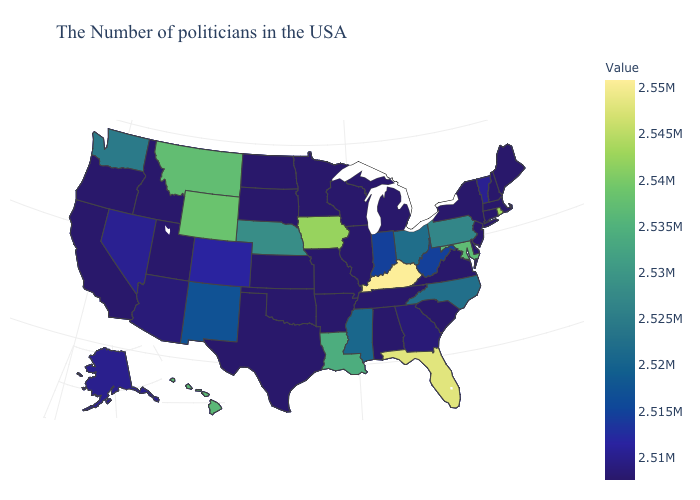Does Michigan have a higher value than West Virginia?
Answer briefly. No. Among the states that border New Mexico , which have the highest value?
Write a very short answer. Colorado. Which states have the lowest value in the USA?
Concise answer only. Maine, Massachusetts, New Hampshire, Connecticut, New York, New Jersey, Delaware, Virginia, South Carolina, Michigan, Alabama, Tennessee, Wisconsin, Illinois, Missouri, Arkansas, Minnesota, Kansas, Oklahoma, Texas, South Dakota, North Dakota, Utah, Idaho, California, Oregon. Which states have the highest value in the USA?
Be succinct. Kentucky. Does New Hampshire have the lowest value in the Northeast?
Keep it brief. Yes. 